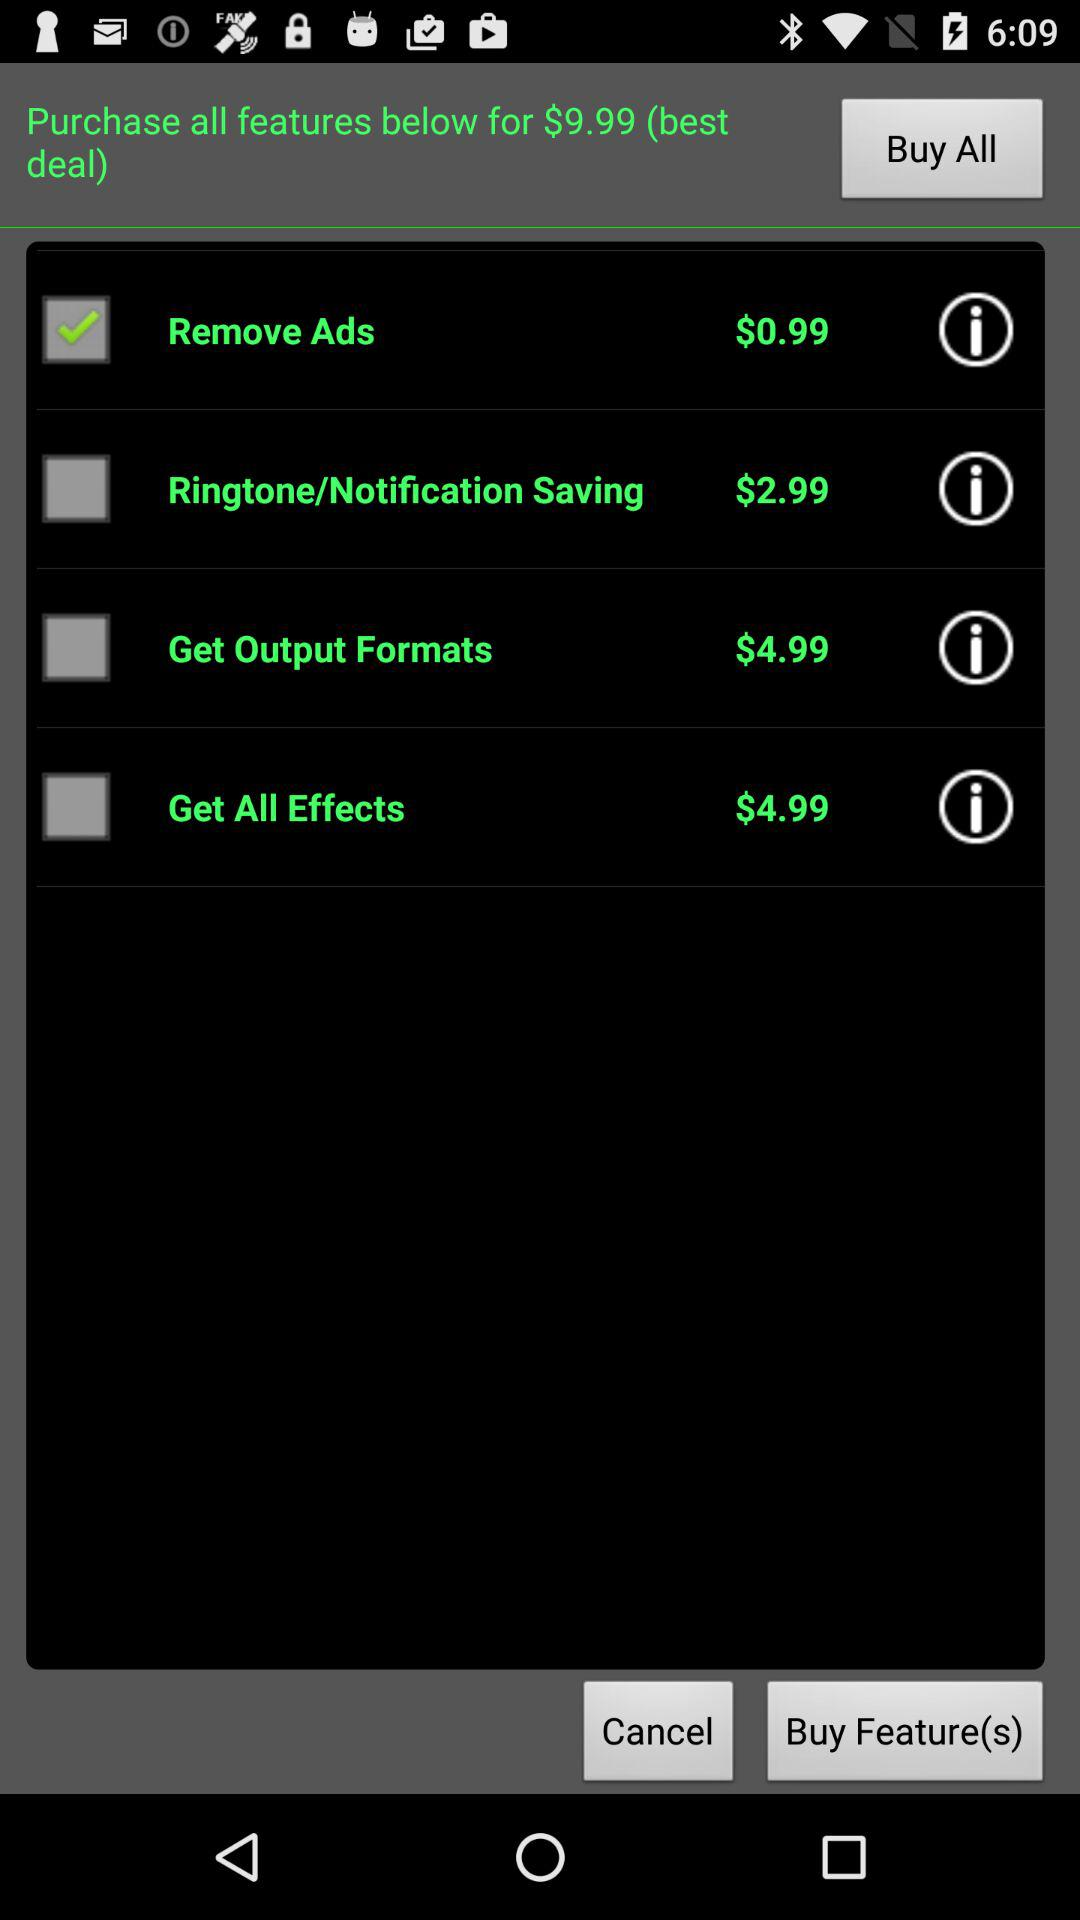What is the name of the application?
When the provided information is insufficient, respond with <no answer>. <no answer> 